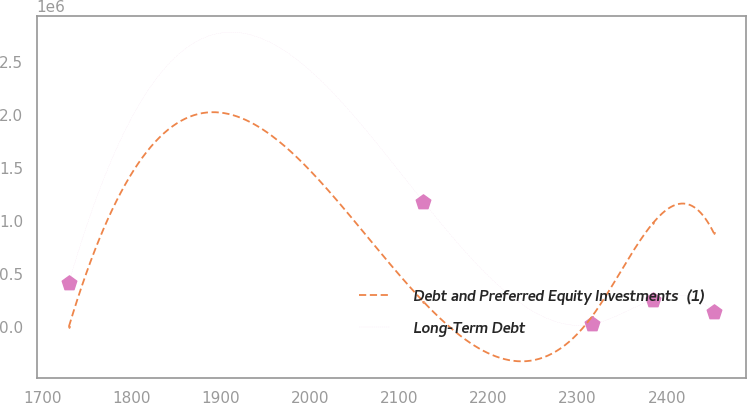Convert chart. <chart><loc_0><loc_0><loc_500><loc_500><line_chart><ecel><fcel>Debt and Preferred Equity Investments  (1)<fcel>Long-Term Debt<nl><fcel>1730<fcel>7435.61<fcel>420878<nl><fcel>2127.27<fcel>242538<fcel>1.18577e+06<nl><fcel>2315.64<fcel>96674.1<fcel>28854.5<nl><fcel>2384.15<fcel>980518<fcel>260237<nl><fcel>2452.66<fcel>891279<fcel>144546<nl></chart> 